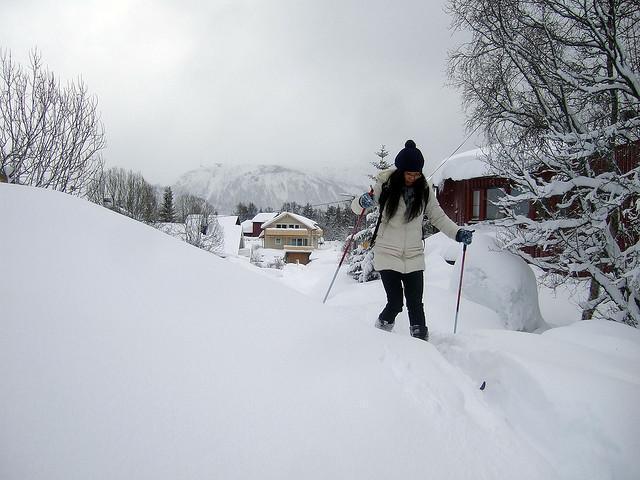How many zebras have their back turned to the camera?
Give a very brief answer. 0. 